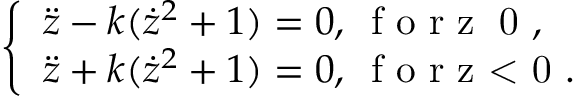Convert formula to latex. <formula><loc_0><loc_0><loc_500><loc_500>\left \{ \begin{array} { l l } { \ddot { z } - k ( \dot { z } ^ { 2 } + 1 ) = 0 , \, f o r z \geq 0 , } \\ { \ddot { z } + k ( \dot { z } ^ { 2 } + 1 ) = 0 , \, f o r z < 0 . } \end{array}</formula> 